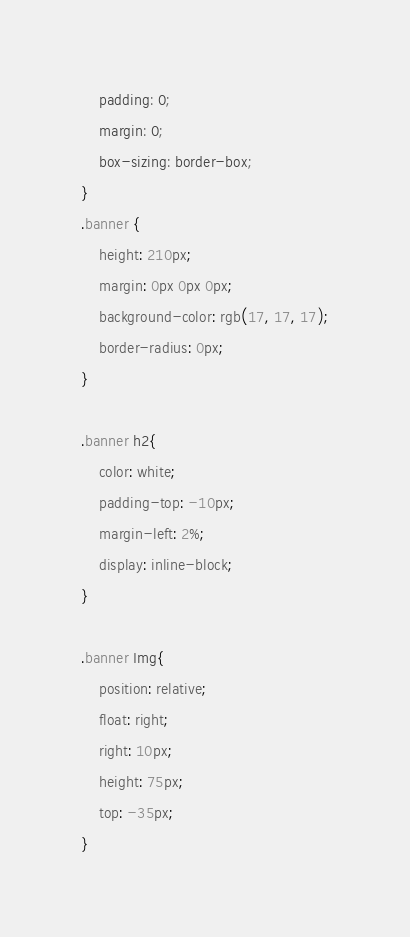<code> <loc_0><loc_0><loc_500><loc_500><_CSS_>    padding: 0;
    margin: 0;
    box-sizing: border-box;
}
.banner {
    height: 210px;
    margin: 0px 0px 0px;
    background-color: rgb(17, 17, 17);
    border-radius: 0px;
}

.banner h2{
    color: white;
    padding-top: -10px;
    margin-left: 2%;
    display: inline-block;
}

.banner Img{
    position: relative;
    float: right;
    right: 10px;
    height: 75px;
    top: -35px;
}
</code> 